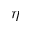<formula> <loc_0><loc_0><loc_500><loc_500>\eta</formula> 